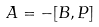Convert formula to latex. <formula><loc_0><loc_0><loc_500><loc_500>A = - [ B , P ]</formula> 